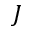<formula> <loc_0><loc_0><loc_500><loc_500>J</formula> 